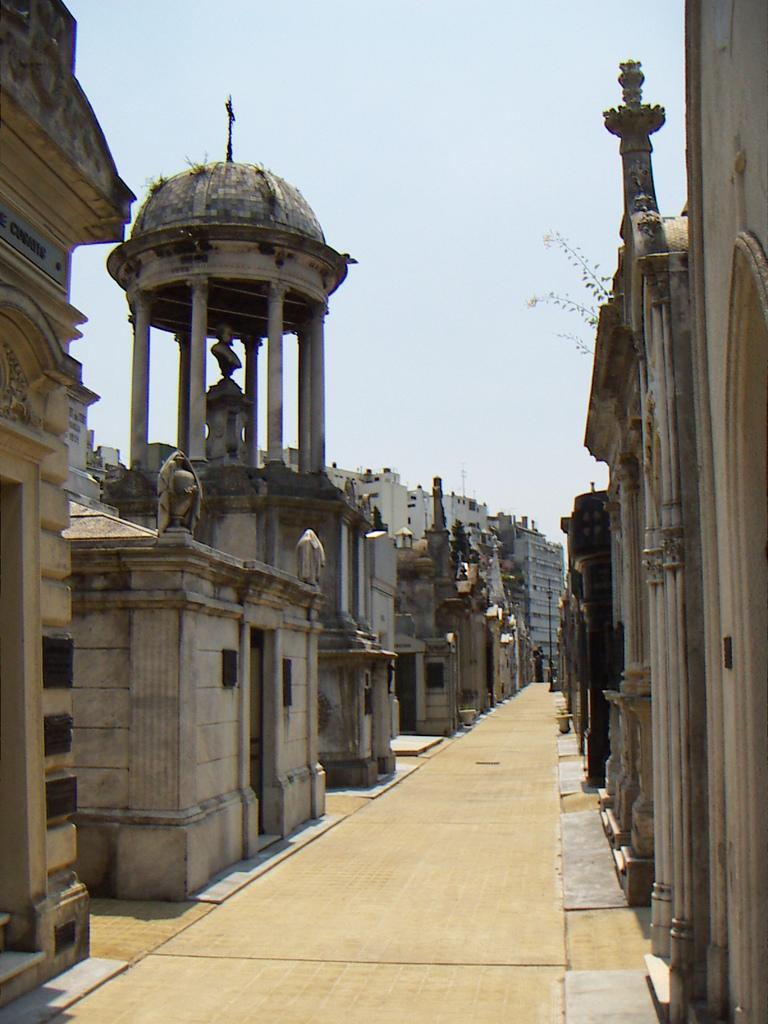What type of structures can be seen in the image? There are buildings in the image. What other objects or features are present in the image? There is a plant, a statue, and a roof above the statue. Are there any architectural elements surrounding the statue? Yes, there are pillars around the statue. What can be seen in the background of the image? The sky is visible in the background of the image. What type of country is depicted in the image? There is no country depicted in the image; it features buildings, a plant, a statue, and other elements. Is it raining in the image? There is no indication of rain in the image; the sky is visible in the background, but no rain is shown. 